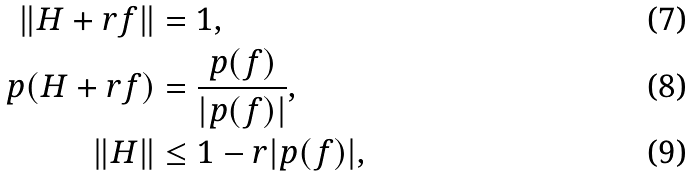Convert formula to latex. <formula><loc_0><loc_0><loc_500><loc_500>\| H + r f \| & = 1 , \\ p ( H + r f ) & = \frac { p ( f ) } { | p ( f ) | } , \\ \| H \| & \leq 1 - r | p ( f ) | ,</formula> 